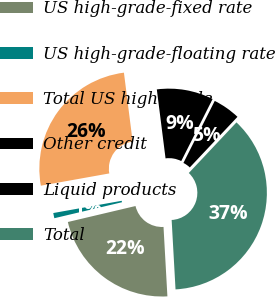Convert chart. <chart><loc_0><loc_0><loc_500><loc_500><pie_chart><fcel>US high-grade-fixed rate<fcel>US high-grade-floating rate<fcel>Total US high-grade<fcel>Other credit<fcel>Liquid products<fcel>Total<nl><fcel>22.2%<fcel>0.87%<fcel>25.82%<fcel>9.45%<fcel>4.58%<fcel>37.09%<nl></chart> 